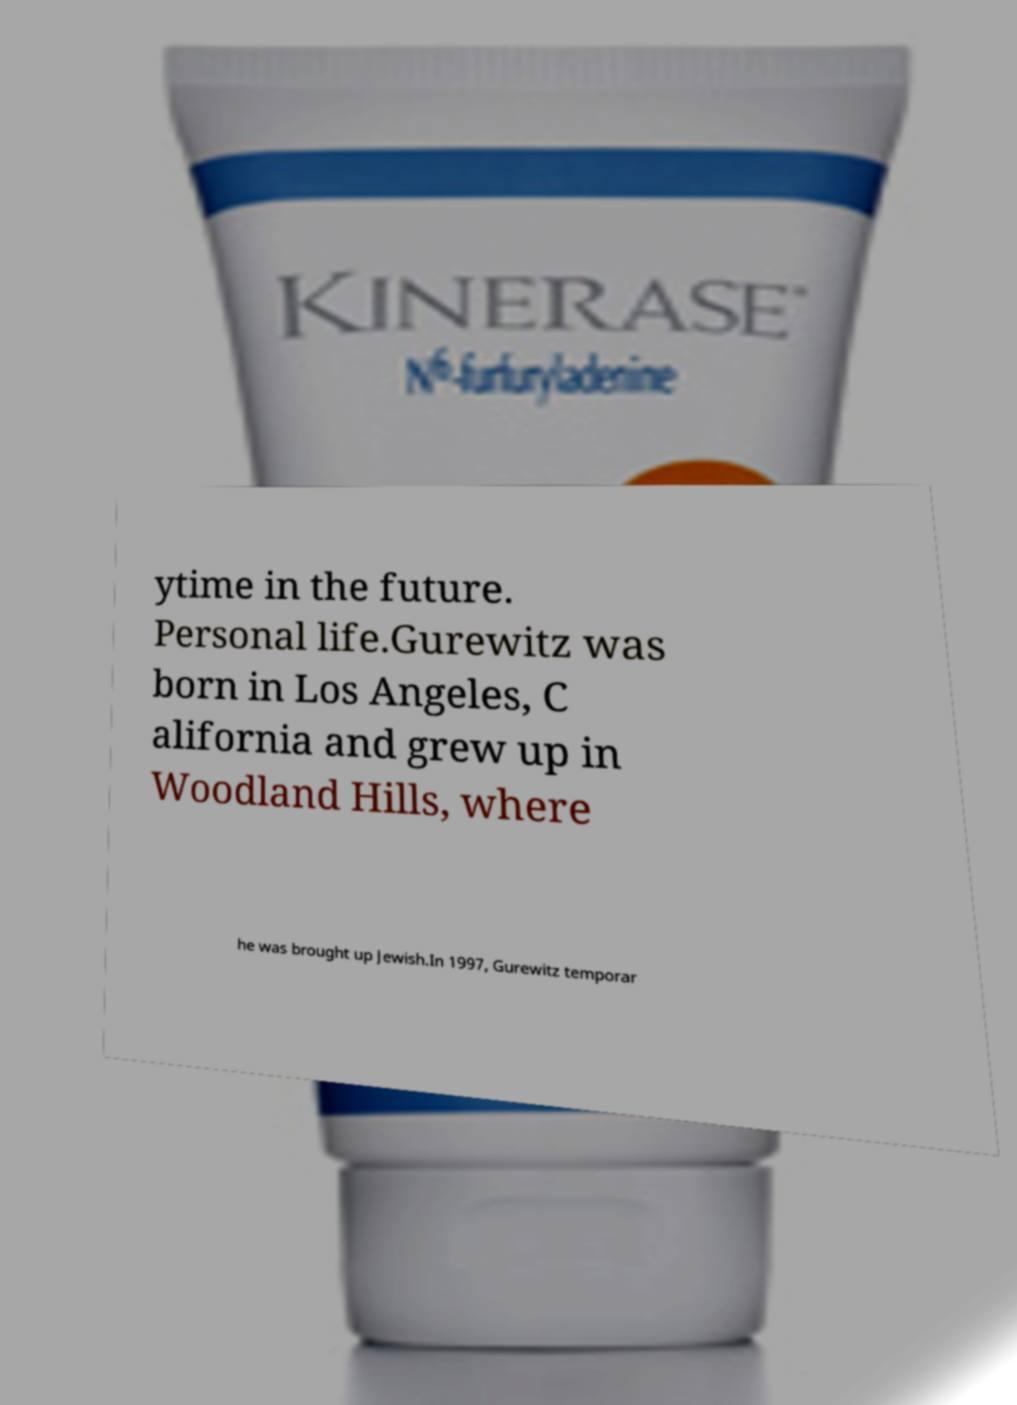Please identify and transcribe the text found in this image. ytime in the future. Personal life.Gurewitz was born in Los Angeles, C alifornia and grew up in Woodland Hills, where he was brought up Jewish.In 1997, Gurewitz temporar 